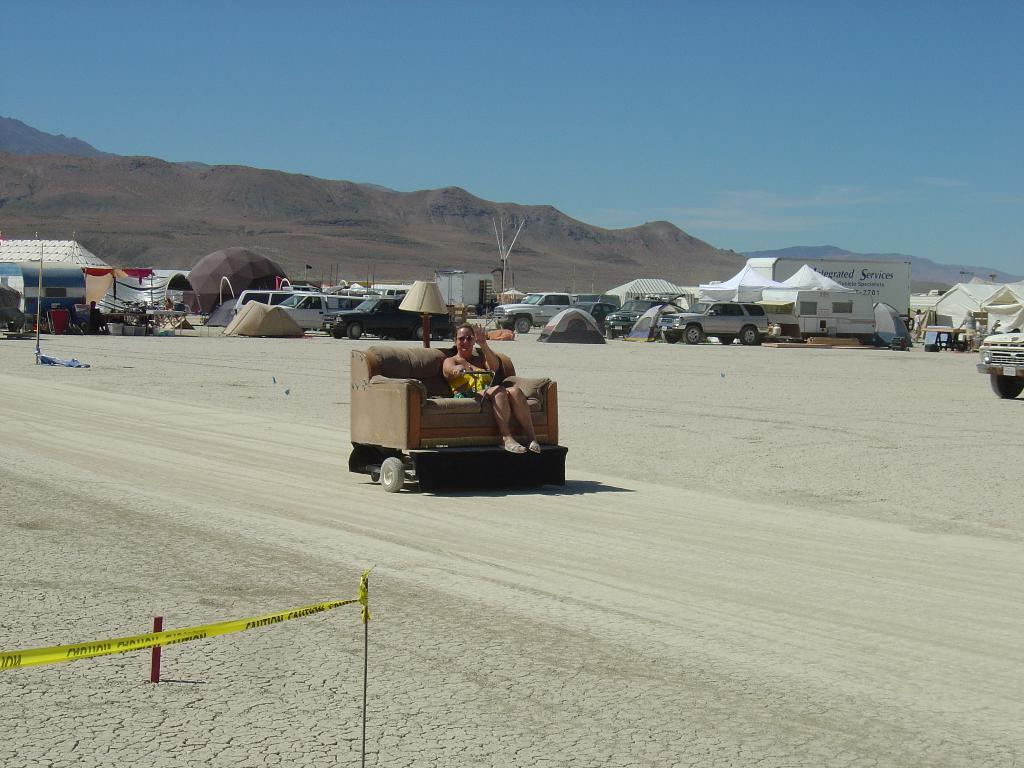What types of objects can be seen in the image? There are vehicles and houses in the image. Can you describe the setting where the woman is sitting? The woman is sitting on a sofa in the image. What is the purpose of the street lamp in the image? The street lamp provides light in the image. What type of natural feature can be seen in the background of the image? There are hills visible in the background of the image. What is visible in the sky in the image? The sky is visible in the image. Where are the dinosaurs grazing in the image? There are no dinosaurs present in the image. What type of stamp is the woman holding in the image? There is no stamp visible in the image. 